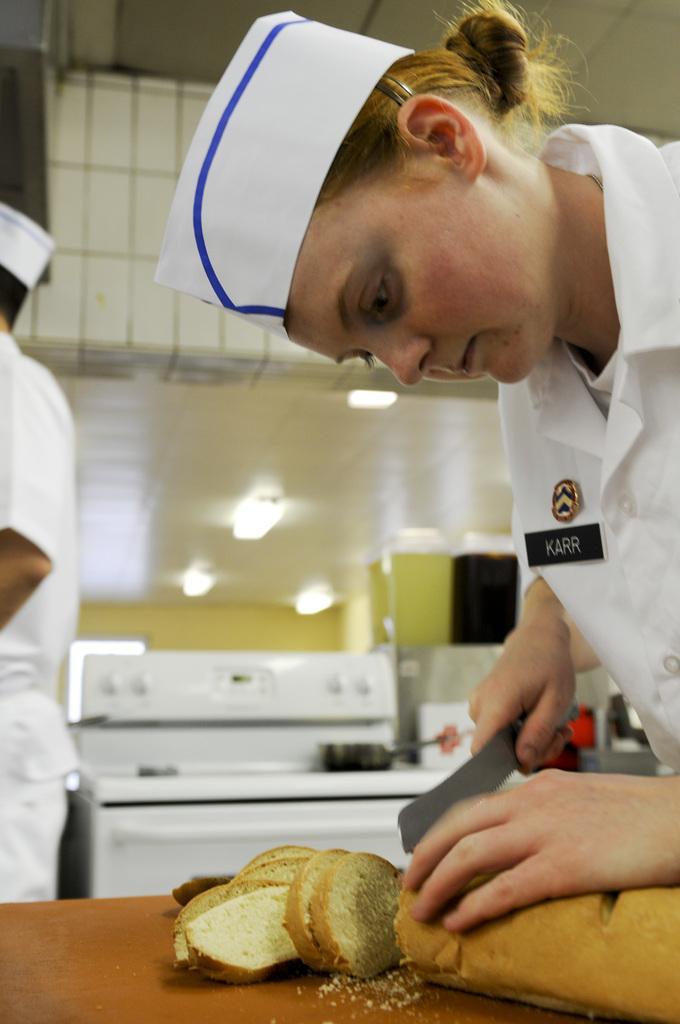Could you give a brief overview of what you see in this image? In this image there is a lady holding a knife in her hand and cutting the bread into pieces, which is on the table. On the left side of the image there is a person standing, beside the person there is a stove and a pan placed on it, beside that there are few kitchen utensils. At the top of the image there is a ceiling with lights. 